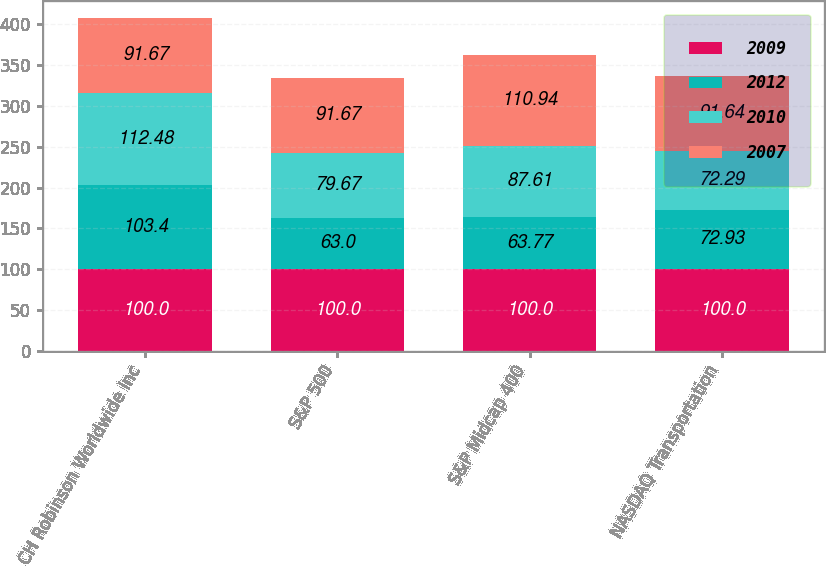Convert chart to OTSL. <chart><loc_0><loc_0><loc_500><loc_500><stacked_bar_chart><ecel><fcel>CH Robinson Worldwide Inc<fcel>S&P 500<fcel>S&P Midcap 400<fcel>NASDAQ Transportation<nl><fcel>2009<fcel>100<fcel>100<fcel>100<fcel>100<nl><fcel>2012<fcel>103.4<fcel>63<fcel>63.77<fcel>72.93<nl><fcel>2010<fcel>112.48<fcel>79.67<fcel>87.61<fcel>72.29<nl><fcel>2007<fcel>91.67<fcel>91.67<fcel>110.94<fcel>91.64<nl></chart> 